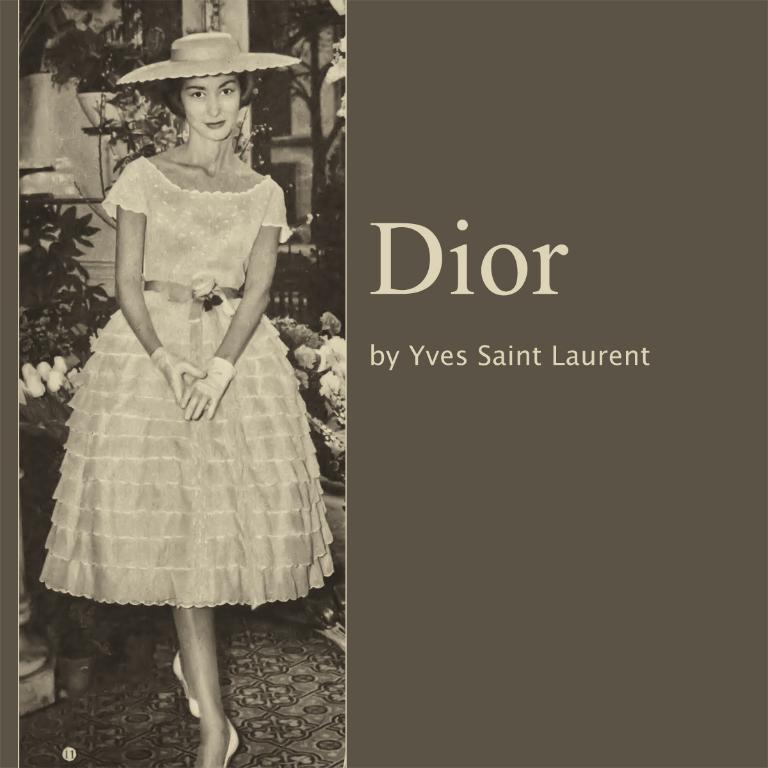<image>
Relay a brief, clear account of the picture shown. The album Dior produced by Yves Saint Laurent 